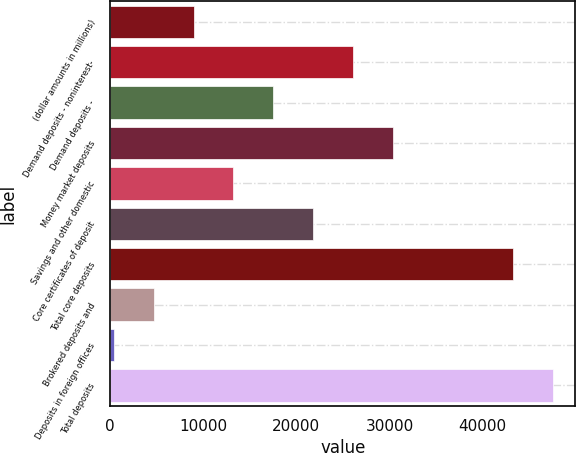Convert chart. <chart><loc_0><loc_0><loc_500><loc_500><bar_chart><fcel>(dollar amounts in millions)<fcel>Demand deposits - noninterest-<fcel>Demand deposits -<fcel>Money market deposits<fcel>Savings and other domestic<fcel>Core certificates of deposit<fcel>Total core deposits<fcel>Brokered deposits and<fcel>Deposits in foreign offices<fcel>Total deposits<nl><fcel>8944.8<fcel>26112.4<fcel>17528.6<fcel>30404.3<fcel>13236.7<fcel>21820.5<fcel>43280<fcel>4652.9<fcel>361<fcel>47571.9<nl></chart> 